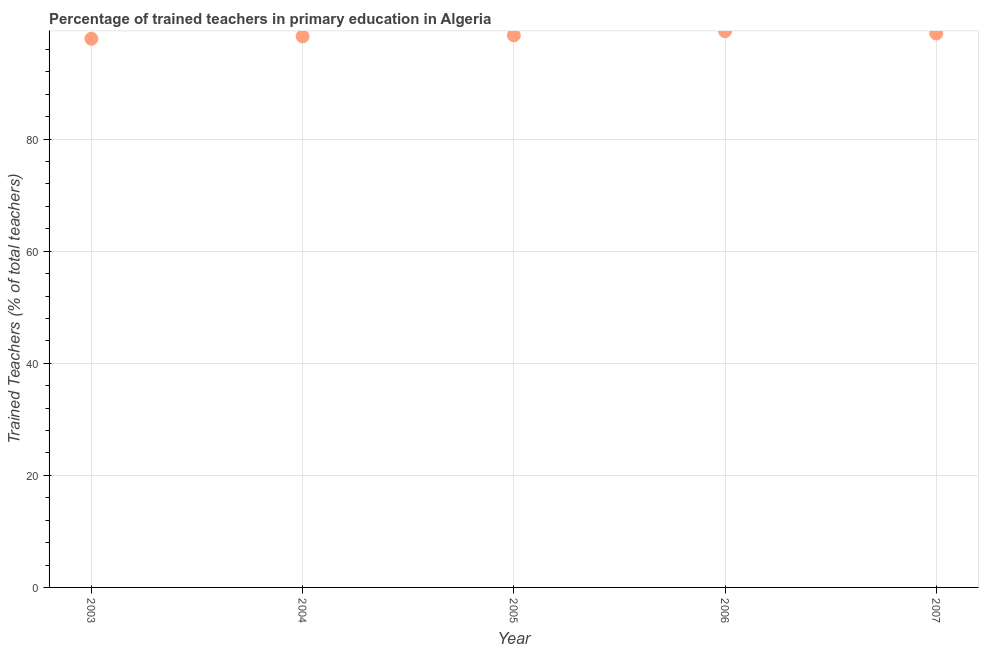What is the percentage of trained teachers in 2007?
Provide a succinct answer. 98.86. Across all years, what is the maximum percentage of trained teachers?
Provide a succinct answer. 99.27. Across all years, what is the minimum percentage of trained teachers?
Ensure brevity in your answer.  97.92. In which year was the percentage of trained teachers maximum?
Provide a short and direct response. 2006. In which year was the percentage of trained teachers minimum?
Give a very brief answer. 2003. What is the sum of the percentage of trained teachers?
Keep it short and to the point. 492.92. What is the difference between the percentage of trained teachers in 2003 and 2006?
Provide a short and direct response. -1.35. What is the average percentage of trained teachers per year?
Provide a succinct answer. 98.58. What is the median percentage of trained teachers?
Give a very brief answer. 98.53. Do a majority of the years between 2007 and 2003 (inclusive) have percentage of trained teachers greater than 64 %?
Your response must be concise. Yes. What is the ratio of the percentage of trained teachers in 2003 to that in 2007?
Your answer should be compact. 0.99. Is the percentage of trained teachers in 2003 less than that in 2005?
Give a very brief answer. Yes. Is the difference between the percentage of trained teachers in 2004 and 2007 greater than the difference between any two years?
Ensure brevity in your answer.  No. What is the difference between the highest and the second highest percentage of trained teachers?
Make the answer very short. 0.41. Is the sum of the percentage of trained teachers in 2003 and 2006 greater than the maximum percentage of trained teachers across all years?
Offer a very short reply. Yes. What is the difference between the highest and the lowest percentage of trained teachers?
Keep it short and to the point. 1.35. Does the percentage of trained teachers monotonically increase over the years?
Give a very brief answer. No. How many years are there in the graph?
Offer a very short reply. 5. What is the difference between two consecutive major ticks on the Y-axis?
Your answer should be very brief. 20. Does the graph contain any zero values?
Provide a short and direct response. No. What is the title of the graph?
Give a very brief answer. Percentage of trained teachers in primary education in Algeria. What is the label or title of the X-axis?
Offer a very short reply. Year. What is the label or title of the Y-axis?
Make the answer very short. Trained Teachers (% of total teachers). What is the Trained Teachers (% of total teachers) in 2003?
Your response must be concise. 97.92. What is the Trained Teachers (% of total teachers) in 2004?
Your answer should be very brief. 98.35. What is the Trained Teachers (% of total teachers) in 2005?
Offer a very short reply. 98.53. What is the Trained Teachers (% of total teachers) in 2006?
Your answer should be very brief. 99.27. What is the Trained Teachers (% of total teachers) in 2007?
Offer a very short reply. 98.86. What is the difference between the Trained Teachers (% of total teachers) in 2003 and 2004?
Offer a very short reply. -0.43. What is the difference between the Trained Teachers (% of total teachers) in 2003 and 2005?
Offer a very short reply. -0.61. What is the difference between the Trained Teachers (% of total teachers) in 2003 and 2006?
Offer a terse response. -1.35. What is the difference between the Trained Teachers (% of total teachers) in 2003 and 2007?
Provide a succinct answer. -0.94. What is the difference between the Trained Teachers (% of total teachers) in 2004 and 2005?
Provide a succinct answer. -0.18. What is the difference between the Trained Teachers (% of total teachers) in 2004 and 2006?
Your answer should be compact. -0.92. What is the difference between the Trained Teachers (% of total teachers) in 2004 and 2007?
Offer a very short reply. -0.51. What is the difference between the Trained Teachers (% of total teachers) in 2005 and 2006?
Give a very brief answer. -0.74. What is the difference between the Trained Teachers (% of total teachers) in 2005 and 2007?
Keep it short and to the point. -0.33. What is the difference between the Trained Teachers (% of total teachers) in 2006 and 2007?
Offer a terse response. 0.41. What is the ratio of the Trained Teachers (% of total teachers) in 2003 to that in 2004?
Ensure brevity in your answer.  1. What is the ratio of the Trained Teachers (% of total teachers) in 2003 to that in 2007?
Keep it short and to the point. 0.99. What is the ratio of the Trained Teachers (% of total teachers) in 2004 to that in 2006?
Keep it short and to the point. 0.99. What is the ratio of the Trained Teachers (% of total teachers) in 2004 to that in 2007?
Provide a succinct answer. 0.99. What is the ratio of the Trained Teachers (% of total teachers) in 2005 to that in 2006?
Keep it short and to the point. 0.99. What is the ratio of the Trained Teachers (% of total teachers) in 2005 to that in 2007?
Give a very brief answer. 1. 